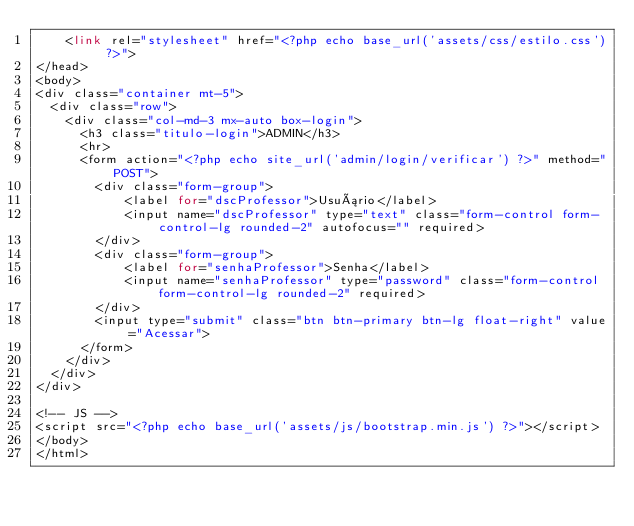Convert code to text. <code><loc_0><loc_0><loc_500><loc_500><_PHP_>    <link rel="stylesheet" href="<?php echo base_url('assets/css/estilo.css') ?>">
</head>
<body>
<div class="container mt-5">
  <div class="row">
    <div class="col-md-3 mx-auto box-login">
      <h3 class="titulo-login">ADMIN</h3>
      <hr>
      <form action="<?php echo site_url('admin/login/verificar') ?>" method="POST">
        <div class="form-group">
            <label for="dscProfessor">Usuário</label>
            <input name="dscProfessor" type="text" class="form-control form-control-lg rounded-2" autofocus="" required>
        </div>
        <div class="form-group">
            <label for="senhaProfessor">Senha</label>
            <input name="senhaProfessor" type="password" class="form-control form-control-lg rounded-2" required>
        </div>
        <input type="submit" class="btn btn-primary btn-lg float-right" value="Acessar">
      </form>
    </div>
  </div>
</div>

<!-- JS -->
<script src="<?php echo base_url('assets/js/bootstrap.min.js') ?>"></script>
</body>
</html></code> 